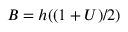<formula> <loc_0><loc_0><loc_500><loc_500>B = h ( ( 1 + U ) / 2 )</formula> 